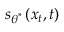<formula> <loc_0><loc_0><loc_500><loc_500>s _ { \theta ^ { * } } \left ( x _ { t } , t \right )</formula> 